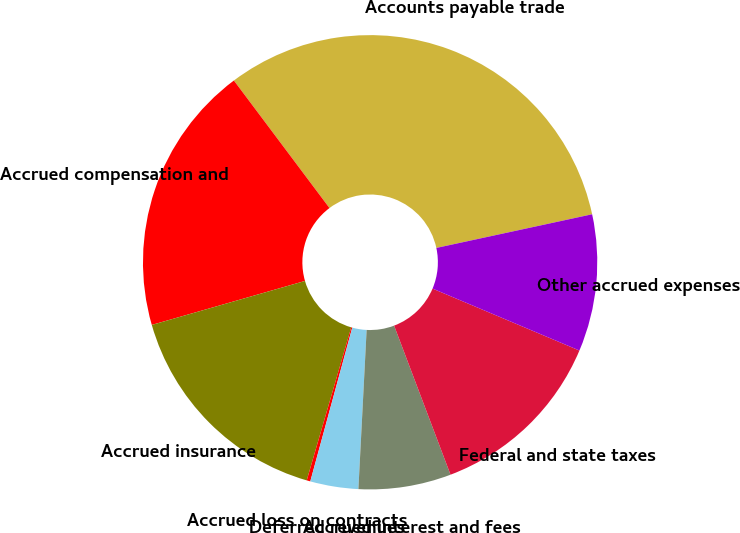Convert chart to OTSL. <chart><loc_0><loc_0><loc_500><loc_500><pie_chart><fcel>Accounts payable trade<fcel>Accrued compensation and<fcel>Accrued insurance<fcel>Accrued loss on contracts<fcel>Deferred revenues<fcel>Accrued interest and fees<fcel>Federal and state taxes<fcel>Other accrued expenses<nl><fcel>31.85%<fcel>19.21%<fcel>16.05%<fcel>0.26%<fcel>3.42%<fcel>6.58%<fcel>12.89%<fcel>9.74%<nl></chart> 